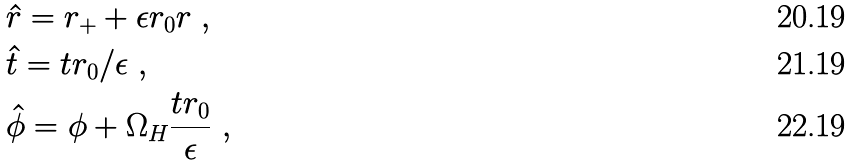Convert formula to latex. <formula><loc_0><loc_0><loc_500><loc_500>& \hat { r } = r _ { + } + \epsilon r _ { 0 } r \ , \\ & \hat { t } = t r _ { 0 } / \epsilon \ , \\ & \hat { \phi } = \phi + \Omega _ { H } \frac { t r _ { 0 } } { \epsilon } \ ,</formula> 